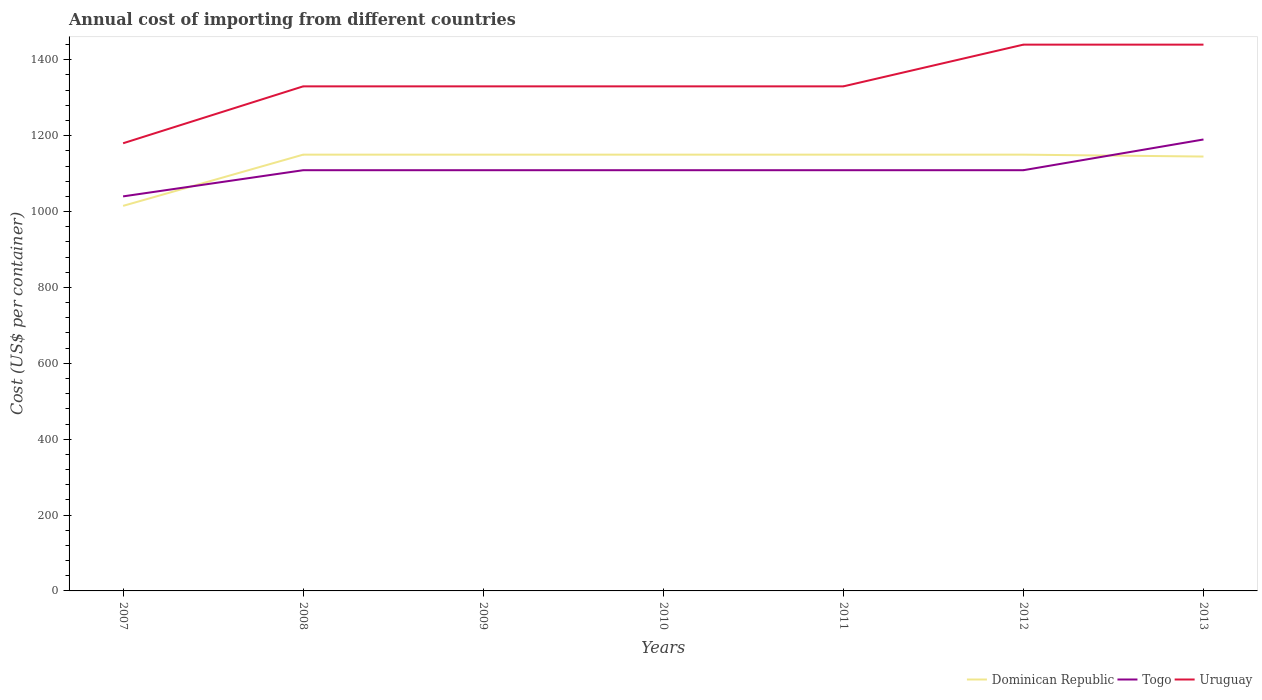How many different coloured lines are there?
Give a very brief answer. 3. Across all years, what is the maximum total annual cost of importing in Dominican Republic?
Ensure brevity in your answer.  1015. In which year was the total annual cost of importing in Togo maximum?
Offer a terse response. 2007. What is the total total annual cost of importing in Togo in the graph?
Make the answer very short. 0. What is the difference between the highest and the second highest total annual cost of importing in Togo?
Offer a very short reply. 150. What is the difference between the highest and the lowest total annual cost of importing in Togo?
Give a very brief answer. 1. What is the difference between two consecutive major ticks on the Y-axis?
Provide a short and direct response. 200. Are the values on the major ticks of Y-axis written in scientific E-notation?
Make the answer very short. No. How are the legend labels stacked?
Offer a very short reply. Horizontal. What is the title of the graph?
Offer a terse response. Annual cost of importing from different countries. Does "Qatar" appear as one of the legend labels in the graph?
Provide a succinct answer. No. What is the label or title of the X-axis?
Offer a very short reply. Years. What is the label or title of the Y-axis?
Your answer should be very brief. Cost (US$ per container). What is the Cost (US$ per container) of Dominican Republic in 2007?
Give a very brief answer. 1015. What is the Cost (US$ per container) in Togo in 2007?
Give a very brief answer. 1040. What is the Cost (US$ per container) in Uruguay in 2007?
Provide a short and direct response. 1180. What is the Cost (US$ per container) of Dominican Republic in 2008?
Offer a very short reply. 1150. What is the Cost (US$ per container) in Togo in 2008?
Provide a succinct answer. 1109. What is the Cost (US$ per container) in Uruguay in 2008?
Keep it short and to the point. 1330. What is the Cost (US$ per container) of Dominican Republic in 2009?
Your answer should be compact. 1150. What is the Cost (US$ per container) in Togo in 2009?
Make the answer very short. 1109. What is the Cost (US$ per container) of Uruguay in 2009?
Offer a terse response. 1330. What is the Cost (US$ per container) in Dominican Republic in 2010?
Keep it short and to the point. 1150. What is the Cost (US$ per container) in Togo in 2010?
Offer a very short reply. 1109. What is the Cost (US$ per container) in Uruguay in 2010?
Provide a succinct answer. 1330. What is the Cost (US$ per container) of Dominican Republic in 2011?
Make the answer very short. 1150. What is the Cost (US$ per container) of Togo in 2011?
Your answer should be very brief. 1109. What is the Cost (US$ per container) in Uruguay in 2011?
Offer a terse response. 1330. What is the Cost (US$ per container) in Dominican Republic in 2012?
Offer a terse response. 1150. What is the Cost (US$ per container) in Togo in 2012?
Provide a short and direct response. 1109. What is the Cost (US$ per container) of Uruguay in 2012?
Provide a short and direct response. 1440. What is the Cost (US$ per container) in Dominican Republic in 2013?
Your response must be concise. 1145. What is the Cost (US$ per container) in Togo in 2013?
Your answer should be very brief. 1190. What is the Cost (US$ per container) in Uruguay in 2013?
Your answer should be very brief. 1440. Across all years, what is the maximum Cost (US$ per container) in Dominican Republic?
Give a very brief answer. 1150. Across all years, what is the maximum Cost (US$ per container) in Togo?
Your answer should be compact. 1190. Across all years, what is the maximum Cost (US$ per container) in Uruguay?
Ensure brevity in your answer.  1440. Across all years, what is the minimum Cost (US$ per container) in Dominican Republic?
Provide a succinct answer. 1015. Across all years, what is the minimum Cost (US$ per container) of Togo?
Give a very brief answer. 1040. Across all years, what is the minimum Cost (US$ per container) in Uruguay?
Offer a terse response. 1180. What is the total Cost (US$ per container) of Dominican Republic in the graph?
Give a very brief answer. 7910. What is the total Cost (US$ per container) of Togo in the graph?
Keep it short and to the point. 7775. What is the total Cost (US$ per container) in Uruguay in the graph?
Offer a very short reply. 9380. What is the difference between the Cost (US$ per container) in Dominican Republic in 2007 and that in 2008?
Keep it short and to the point. -135. What is the difference between the Cost (US$ per container) in Togo in 2007 and that in 2008?
Offer a very short reply. -69. What is the difference between the Cost (US$ per container) of Uruguay in 2007 and that in 2008?
Provide a succinct answer. -150. What is the difference between the Cost (US$ per container) of Dominican Republic in 2007 and that in 2009?
Offer a very short reply. -135. What is the difference between the Cost (US$ per container) of Togo in 2007 and that in 2009?
Provide a short and direct response. -69. What is the difference between the Cost (US$ per container) in Uruguay in 2007 and that in 2009?
Ensure brevity in your answer.  -150. What is the difference between the Cost (US$ per container) of Dominican Republic in 2007 and that in 2010?
Give a very brief answer. -135. What is the difference between the Cost (US$ per container) in Togo in 2007 and that in 2010?
Keep it short and to the point. -69. What is the difference between the Cost (US$ per container) of Uruguay in 2007 and that in 2010?
Give a very brief answer. -150. What is the difference between the Cost (US$ per container) in Dominican Republic in 2007 and that in 2011?
Offer a terse response. -135. What is the difference between the Cost (US$ per container) in Togo in 2007 and that in 2011?
Offer a very short reply. -69. What is the difference between the Cost (US$ per container) of Uruguay in 2007 and that in 2011?
Make the answer very short. -150. What is the difference between the Cost (US$ per container) in Dominican Republic in 2007 and that in 2012?
Give a very brief answer. -135. What is the difference between the Cost (US$ per container) of Togo in 2007 and that in 2012?
Ensure brevity in your answer.  -69. What is the difference between the Cost (US$ per container) in Uruguay in 2007 and that in 2012?
Your answer should be compact. -260. What is the difference between the Cost (US$ per container) in Dominican Republic in 2007 and that in 2013?
Keep it short and to the point. -130. What is the difference between the Cost (US$ per container) of Togo in 2007 and that in 2013?
Give a very brief answer. -150. What is the difference between the Cost (US$ per container) of Uruguay in 2007 and that in 2013?
Provide a succinct answer. -260. What is the difference between the Cost (US$ per container) in Dominican Republic in 2008 and that in 2009?
Give a very brief answer. 0. What is the difference between the Cost (US$ per container) of Uruguay in 2008 and that in 2009?
Keep it short and to the point. 0. What is the difference between the Cost (US$ per container) in Dominican Republic in 2008 and that in 2011?
Make the answer very short. 0. What is the difference between the Cost (US$ per container) in Uruguay in 2008 and that in 2011?
Your answer should be compact. 0. What is the difference between the Cost (US$ per container) in Dominican Republic in 2008 and that in 2012?
Provide a short and direct response. 0. What is the difference between the Cost (US$ per container) of Uruguay in 2008 and that in 2012?
Provide a succinct answer. -110. What is the difference between the Cost (US$ per container) in Dominican Republic in 2008 and that in 2013?
Your answer should be very brief. 5. What is the difference between the Cost (US$ per container) of Togo in 2008 and that in 2013?
Give a very brief answer. -81. What is the difference between the Cost (US$ per container) of Uruguay in 2008 and that in 2013?
Your answer should be very brief. -110. What is the difference between the Cost (US$ per container) of Togo in 2009 and that in 2010?
Offer a terse response. 0. What is the difference between the Cost (US$ per container) in Uruguay in 2009 and that in 2010?
Ensure brevity in your answer.  0. What is the difference between the Cost (US$ per container) in Togo in 2009 and that in 2011?
Make the answer very short. 0. What is the difference between the Cost (US$ per container) in Uruguay in 2009 and that in 2012?
Ensure brevity in your answer.  -110. What is the difference between the Cost (US$ per container) of Dominican Republic in 2009 and that in 2013?
Keep it short and to the point. 5. What is the difference between the Cost (US$ per container) in Togo in 2009 and that in 2013?
Make the answer very short. -81. What is the difference between the Cost (US$ per container) of Uruguay in 2009 and that in 2013?
Make the answer very short. -110. What is the difference between the Cost (US$ per container) of Dominican Republic in 2010 and that in 2011?
Your answer should be very brief. 0. What is the difference between the Cost (US$ per container) in Togo in 2010 and that in 2011?
Keep it short and to the point. 0. What is the difference between the Cost (US$ per container) of Togo in 2010 and that in 2012?
Your response must be concise. 0. What is the difference between the Cost (US$ per container) of Uruguay in 2010 and that in 2012?
Ensure brevity in your answer.  -110. What is the difference between the Cost (US$ per container) in Togo in 2010 and that in 2013?
Provide a succinct answer. -81. What is the difference between the Cost (US$ per container) of Uruguay in 2010 and that in 2013?
Provide a succinct answer. -110. What is the difference between the Cost (US$ per container) of Uruguay in 2011 and that in 2012?
Give a very brief answer. -110. What is the difference between the Cost (US$ per container) in Togo in 2011 and that in 2013?
Your answer should be very brief. -81. What is the difference between the Cost (US$ per container) of Uruguay in 2011 and that in 2013?
Your response must be concise. -110. What is the difference between the Cost (US$ per container) in Togo in 2012 and that in 2013?
Your response must be concise. -81. What is the difference between the Cost (US$ per container) of Dominican Republic in 2007 and the Cost (US$ per container) of Togo in 2008?
Provide a succinct answer. -94. What is the difference between the Cost (US$ per container) in Dominican Republic in 2007 and the Cost (US$ per container) in Uruguay in 2008?
Offer a terse response. -315. What is the difference between the Cost (US$ per container) in Togo in 2007 and the Cost (US$ per container) in Uruguay in 2008?
Make the answer very short. -290. What is the difference between the Cost (US$ per container) of Dominican Republic in 2007 and the Cost (US$ per container) of Togo in 2009?
Ensure brevity in your answer.  -94. What is the difference between the Cost (US$ per container) in Dominican Republic in 2007 and the Cost (US$ per container) in Uruguay in 2009?
Offer a very short reply. -315. What is the difference between the Cost (US$ per container) of Togo in 2007 and the Cost (US$ per container) of Uruguay in 2009?
Make the answer very short. -290. What is the difference between the Cost (US$ per container) of Dominican Republic in 2007 and the Cost (US$ per container) of Togo in 2010?
Your answer should be very brief. -94. What is the difference between the Cost (US$ per container) in Dominican Republic in 2007 and the Cost (US$ per container) in Uruguay in 2010?
Your answer should be very brief. -315. What is the difference between the Cost (US$ per container) of Togo in 2007 and the Cost (US$ per container) of Uruguay in 2010?
Ensure brevity in your answer.  -290. What is the difference between the Cost (US$ per container) of Dominican Republic in 2007 and the Cost (US$ per container) of Togo in 2011?
Ensure brevity in your answer.  -94. What is the difference between the Cost (US$ per container) of Dominican Republic in 2007 and the Cost (US$ per container) of Uruguay in 2011?
Your response must be concise. -315. What is the difference between the Cost (US$ per container) of Togo in 2007 and the Cost (US$ per container) of Uruguay in 2011?
Offer a terse response. -290. What is the difference between the Cost (US$ per container) of Dominican Republic in 2007 and the Cost (US$ per container) of Togo in 2012?
Your answer should be compact. -94. What is the difference between the Cost (US$ per container) in Dominican Republic in 2007 and the Cost (US$ per container) in Uruguay in 2012?
Provide a succinct answer. -425. What is the difference between the Cost (US$ per container) in Togo in 2007 and the Cost (US$ per container) in Uruguay in 2012?
Keep it short and to the point. -400. What is the difference between the Cost (US$ per container) in Dominican Republic in 2007 and the Cost (US$ per container) in Togo in 2013?
Offer a very short reply. -175. What is the difference between the Cost (US$ per container) of Dominican Republic in 2007 and the Cost (US$ per container) of Uruguay in 2013?
Offer a very short reply. -425. What is the difference between the Cost (US$ per container) of Togo in 2007 and the Cost (US$ per container) of Uruguay in 2013?
Your answer should be very brief. -400. What is the difference between the Cost (US$ per container) in Dominican Republic in 2008 and the Cost (US$ per container) in Uruguay in 2009?
Make the answer very short. -180. What is the difference between the Cost (US$ per container) in Togo in 2008 and the Cost (US$ per container) in Uruguay in 2009?
Keep it short and to the point. -221. What is the difference between the Cost (US$ per container) of Dominican Republic in 2008 and the Cost (US$ per container) of Togo in 2010?
Your response must be concise. 41. What is the difference between the Cost (US$ per container) in Dominican Republic in 2008 and the Cost (US$ per container) in Uruguay in 2010?
Keep it short and to the point. -180. What is the difference between the Cost (US$ per container) in Togo in 2008 and the Cost (US$ per container) in Uruguay in 2010?
Ensure brevity in your answer.  -221. What is the difference between the Cost (US$ per container) in Dominican Republic in 2008 and the Cost (US$ per container) in Uruguay in 2011?
Your response must be concise. -180. What is the difference between the Cost (US$ per container) of Togo in 2008 and the Cost (US$ per container) of Uruguay in 2011?
Ensure brevity in your answer.  -221. What is the difference between the Cost (US$ per container) of Dominican Republic in 2008 and the Cost (US$ per container) of Togo in 2012?
Provide a succinct answer. 41. What is the difference between the Cost (US$ per container) in Dominican Republic in 2008 and the Cost (US$ per container) in Uruguay in 2012?
Your response must be concise. -290. What is the difference between the Cost (US$ per container) of Togo in 2008 and the Cost (US$ per container) of Uruguay in 2012?
Make the answer very short. -331. What is the difference between the Cost (US$ per container) of Dominican Republic in 2008 and the Cost (US$ per container) of Togo in 2013?
Your answer should be compact. -40. What is the difference between the Cost (US$ per container) in Dominican Republic in 2008 and the Cost (US$ per container) in Uruguay in 2013?
Make the answer very short. -290. What is the difference between the Cost (US$ per container) in Togo in 2008 and the Cost (US$ per container) in Uruguay in 2013?
Your answer should be very brief. -331. What is the difference between the Cost (US$ per container) of Dominican Republic in 2009 and the Cost (US$ per container) of Uruguay in 2010?
Your answer should be compact. -180. What is the difference between the Cost (US$ per container) in Togo in 2009 and the Cost (US$ per container) in Uruguay in 2010?
Offer a very short reply. -221. What is the difference between the Cost (US$ per container) of Dominican Republic in 2009 and the Cost (US$ per container) of Togo in 2011?
Your answer should be compact. 41. What is the difference between the Cost (US$ per container) of Dominican Republic in 2009 and the Cost (US$ per container) of Uruguay in 2011?
Your answer should be compact. -180. What is the difference between the Cost (US$ per container) of Togo in 2009 and the Cost (US$ per container) of Uruguay in 2011?
Your response must be concise. -221. What is the difference between the Cost (US$ per container) of Dominican Republic in 2009 and the Cost (US$ per container) of Uruguay in 2012?
Your response must be concise. -290. What is the difference between the Cost (US$ per container) of Togo in 2009 and the Cost (US$ per container) of Uruguay in 2012?
Your response must be concise. -331. What is the difference between the Cost (US$ per container) in Dominican Republic in 2009 and the Cost (US$ per container) in Uruguay in 2013?
Your answer should be very brief. -290. What is the difference between the Cost (US$ per container) of Togo in 2009 and the Cost (US$ per container) of Uruguay in 2013?
Keep it short and to the point. -331. What is the difference between the Cost (US$ per container) in Dominican Republic in 2010 and the Cost (US$ per container) in Togo in 2011?
Ensure brevity in your answer.  41. What is the difference between the Cost (US$ per container) in Dominican Republic in 2010 and the Cost (US$ per container) in Uruguay in 2011?
Your answer should be very brief. -180. What is the difference between the Cost (US$ per container) of Togo in 2010 and the Cost (US$ per container) of Uruguay in 2011?
Give a very brief answer. -221. What is the difference between the Cost (US$ per container) of Dominican Republic in 2010 and the Cost (US$ per container) of Togo in 2012?
Provide a succinct answer. 41. What is the difference between the Cost (US$ per container) in Dominican Republic in 2010 and the Cost (US$ per container) in Uruguay in 2012?
Ensure brevity in your answer.  -290. What is the difference between the Cost (US$ per container) of Togo in 2010 and the Cost (US$ per container) of Uruguay in 2012?
Your answer should be very brief. -331. What is the difference between the Cost (US$ per container) in Dominican Republic in 2010 and the Cost (US$ per container) in Togo in 2013?
Keep it short and to the point. -40. What is the difference between the Cost (US$ per container) of Dominican Republic in 2010 and the Cost (US$ per container) of Uruguay in 2013?
Provide a succinct answer. -290. What is the difference between the Cost (US$ per container) in Togo in 2010 and the Cost (US$ per container) in Uruguay in 2013?
Your response must be concise. -331. What is the difference between the Cost (US$ per container) of Dominican Republic in 2011 and the Cost (US$ per container) of Togo in 2012?
Give a very brief answer. 41. What is the difference between the Cost (US$ per container) in Dominican Republic in 2011 and the Cost (US$ per container) in Uruguay in 2012?
Give a very brief answer. -290. What is the difference between the Cost (US$ per container) of Togo in 2011 and the Cost (US$ per container) of Uruguay in 2012?
Give a very brief answer. -331. What is the difference between the Cost (US$ per container) in Dominican Republic in 2011 and the Cost (US$ per container) in Uruguay in 2013?
Your response must be concise. -290. What is the difference between the Cost (US$ per container) of Togo in 2011 and the Cost (US$ per container) of Uruguay in 2013?
Your answer should be very brief. -331. What is the difference between the Cost (US$ per container) in Dominican Republic in 2012 and the Cost (US$ per container) in Uruguay in 2013?
Offer a terse response. -290. What is the difference between the Cost (US$ per container) in Togo in 2012 and the Cost (US$ per container) in Uruguay in 2013?
Make the answer very short. -331. What is the average Cost (US$ per container) in Dominican Republic per year?
Give a very brief answer. 1130. What is the average Cost (US$ per container) of Togo per year?
Offer a terse response. 1110.71. What is the average Cost (US$ per container) in Uruguay per year?
Ensure brevity in your answer.  1340. In the year 2007, what is the difference between the Cost (US$ per container) of Dominican Republic and Cost (US$ per container) of Togo?
Keep it short and to the point. -25. In the year 2007, what is the difference between the Cost (US$ per container) in Dominican Republic and Cost (US$ per container) in Uruguay?
Give a very brief answer. -165. In the year 2007, what is the difference between the Cost (US$ per container) of Togo and Cost (US$ per container) of Uruguay?
Provide a succinct answer. -140. In the year 2008, what is the difference between the Cost (US$ per container) in Dominican Republic and Cost (US$ per container) in Togo?
Your answer should be very brief. 41. In the year 2008, what is the difference between the Cost (US$ per container) in Dominican Republic and Cost (US$ per container) in Uruguay?
Provide a short and direct response. -180. In the year 2008, what is the difference between the Cost (US$ per container) of Togo and Cost (US$ per container) of Uruguay?
Make the answer very short. -221. In the year 2009, what is the difference between the Cost (US$ per container) in Dominican Republic and Cost (US$ per container) in Uruguay?
Make the answer very short. -180. In the year 2009, what is the difference between the Cost (US$ per container) of Togo and Cost (US$ per container) of Uruguay?
Keep it short and to the point. -221. In the year 2010, what is the difference between the Cost (US$ per container) of Dominican Republic and Cost (US$ per container) of Uruguay?
Your answer should be very brief. -180. In the year 2010, what is the difference between the Cost (US$ per container) in Togo and Cost (US$ per container) in Uruguay?
Make the answer very short. -221. In the year 2011, what is the difference between the Cost (US$ per container) of Dominican Republic and Cost (US$ per container) of Togo?
Give a very brief answer. 41. In the year 2011, what is the difference between the Cost (US$ per container) in Dominican Republic and Cost (US$ per container) in Uruguay?
Provide a succinct answer. -180. In the year 2011, what is the difference between the Cost (US$ per container) in Togo and Cost (US$ per container) in Uruguay?
Make the answer very short. -221. In the year 2012, what is the difference between the Cost (US$ per container) of Dominican Republic and Cost (US$ per container) of Uruguay?
Keep it short and to the point. -290. In the year 2012, what is the difference between the Cost (US$ per container) of Togo and Cost (US$ per container) of Uruguay?
Offer a terse response. -331. In the year 2013, what is the difference between the Cost (US$ per container) of Dominican Republic and Cost (US$ per container) of Togo?
Provide a succinct answer. -45. In the year 2013, what is the difference between the Cost (US$ per container) in Dominican Republic and Cost (US$ per container) in Uruguay?
Provide a short and direct response. -295. In the year 2013, what is the difference between the Cost (US$ per container) in Togo and Cost (US$ per container) in Uruguay?
Your answer should be very brief. -250. What is the ratio of the Cost (US$ per container) of Dominican Republic in 2007 to that in 2008?
Make the answer very short. 0.88. What is the ratio of the Cost (US$ per container) in Togo in 2007 to that in 2008?
Your answer should be compact. 0.94. What is the ratio of the Cost (US$ per container) in Uruguay in 2007 to that in 2008?
Provide a succinct answer. 0.89. What is the ratio of the Cost (US$ per container) of Dominican Republic in 2007 to that in 2009?
Ensure brevity in your answer.  0.88. What is the ratio of the Cost (US$ per container) in Togo in 2007 to that in 2009?
Your answer should be very brief. 0.94. What is the ratio of the Cost (US$ per container) in Uruguay in 2007 to that in 2009?
Keep it short and to the point. 0.89. What is the ratio of the Cost (US$ per container) of Dominican Republic in 2007 to that in 2010?
Offer a very short reply. 0.88. What is the ratio of the Cost (US$ per container) in Togo in 2007 to that in 2010?
Your answer should be compact. 0.94. What is the ratio of the Cost (US$ per container) of Uruguay in 2007 to that in 2010?
Your response must be concise. 0.89. What is the ratio of the Cost (US$ per container) of Dominican Republic in 2007 to that in 2011?
Your response must be concise. 0.88. What is the ratio of the Cost (US$ per container) in Togo in 2007 to that in 2011?
Your response must be concise. 0.94. What is the ratio of the Cost (US$ per container) of Uruguay in 2007 to that in 2011?
Give a very brief answer. 0.89. What is the ratio of the Cost (US$ per container) of Dominican Republic in 2007 to that in 2012?
Provide a short and direct response. 0.88. What is the ratio of the Cost (US$ per container) of Togo in 2007 to that in 2012?
Provide a succinct answer. 0.94. What is the ratio of the Cost (US$ per container) in Uruguay in 2007 to that in 2012?
Offer a terse response. 0.82. What is the ratio of the Cost (US$ per container) of Dominican Republic in 2007 to that in 2013?
Offer a very short reply. 0.89. What is the ratio of the Cost (US$ per container) in Togo in 2007 to that in 2013?
Your response must be concise. 0.87. What is the ratio of the Cost (US$ per container) of Uruguay in 2007 to that in 2013?
Keep it short and to the point. 0.82. What is the ratio of the Cost (US$ per container) in Dominican Republic in 2008 to that in 2010?
Make the answer very short. 1. What is the ratio of the Cost (US$ per container) in Togo in 2008 to that in 2010?
Offer a very short reply. 1. What is the ratio of the Cost (US$ per container) of Uruguay in 2008 to that in 2010?
Ensure brevity in your answer.  1. What is the ratio of the Cost (US$ per container) of Dominican Republic in 2008 to that in 2011?
Your response must be concise. 1. What is the ratio of the Cost (US$ per container) in Togo in 2008 to that in 2011?
Offer a terse response. 1. What is the ratio of the Cost (US$ per container) of Uruguay in 2008 to that in 2011?
Offer a very short reply. 1. What is the ratio of the Cost (US$ per container) in Dominican Republic in 2008 to that in 2012?
Provide a short and direct response. 1. What is the ratio of the Cost (US$ per container) of Togo in 2008 to that in 2012?
Provide a succinct answer. 1. What is the ratio of the Cost (US$ per container) of Uruguay in 2008 to that in 2012?
Give a very brief answer. 0.92. What is the ratio of the Cost (US$ per container) of Dominican Republic in 2008 to that in 2013?
Your answer should be compact. 1. What is the ratio of the Cost (US$ per container) of Togo in 2008 to that in 2013?
Offer a terse response. 0.93. What is the ratio of the Cost (US$ per container) of Uruguay in 2008 to that in 2013?
Your answer should be compact. 0.92. What is the ratio of the Cost (US$ per container) of Dominican Republic in 2009 to that in 2010?
Your response must be concise. 1. What is the ratio of the Cost (US$ per container) of Togo in 2009 to that in 2011?
Make the answer very short. 1. What is the ratio of the Cost (US$ per container) of Uruguay in 2009 to that in 2011?
Your answer should be very brief. 1. What is the ratio of the Cost (US$ per container) in Dominican Republic in 2009 to that in 2012?
Your answer should be very brief. 1. What is the ratio of the Cost (US$ per container) of Uruguay in 2009 to that in 2012?
Your response must be concise. 0.92. What is the ratio of the Cost (US$ per container) of Togo in 2009 to that in 2013?
Your answer should be very brief. 0.93. What is the ratio of the Cost (US$ per container) of Uruguay in 2009 to that in 2013?
Your answer should be very brief. 0.92. What is the ratio of the Cost (US$ per container) of Dominican Republic in 2010 to that in 2011?
Offer a very short reply. 1. What is the ratio of the Cost (US$ per container) in Uruguay in 2010 to that in 2011?
Your answer should be very brief. 1. What is the ratio of the Cost (US$ per container) of Dominican Republic in 2010 to that in 2012?
Keep it short and to the point. 1. What is the ratio of the Cost (US$ per container) of Togo in 2010 to that in 2012?
Provide a short and direct response. 1. What is the ratio of the Cost (US$ per container) of Uruguay in 2010 to that in 2012?
Give a very brief answer. 0.92. What is the ratio of the Cost (US$ per container) of Dominican Republic in 2010 to that in 2013?
Your response must be concise. 1. What is the ratio of the Cost (US$ per container) in Togo in 2010 to that in 2013?
Your answer should be very brief. 0.93. What is the ratio of the Cost (US$ per container) in Uruguay in 2010 to that in 2013?
Offer a terse response. 0.92. What is the ratio of the Cost (US$ per container) of Uruguay in 2011 to that in 2012?
Give a very brief answer. 0.92. What is the ratio of the Cost (US$ per container) of Togo in 2011 to that in 2013?
Ensure brevity in your answer.  0.93. What is the ratio of the Cost (US$ per container) in Uruguay in 2011 to that in 2013?
Offer a very short reply. 0.92. What is the ratio of the Cost (US$ per container) of Togo in 2012 to that in 2013?
Offer a very short reply. 0.93. What is the ratio of the Cost (US$ per container) in Uruguay in 2012 to that in 2013?
Ensure brevity in your answer.  1. What is the difference between the highest and the second highest Cost (US$ per container) in Dominican Republic?
Your answer should be compact. 0. What is the difference between the highest and the second highest Cost (US$ per container) in Togo?
Your answer should be very brief. 81. What is the difference between the highest and the lowest Cost (US$ per container) of Dominican Republic?
Offer a very short reply. 135. What is the difference between the highest and the lowest Cost (US$ per container) in Togo?
Ensure brevity in your answer.  150. What is the difference between the highest and the lowest Cost (US$ per container) in Uruguay?
Ensure brevity in your answer.  260. 